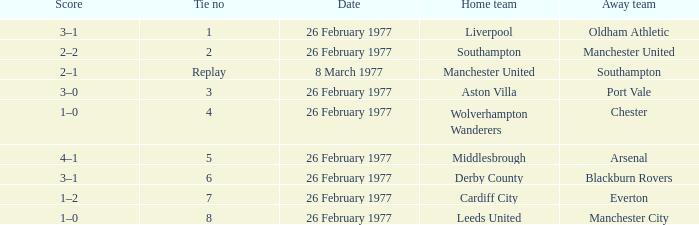What's the score when the tie number was 6? 3–1. 